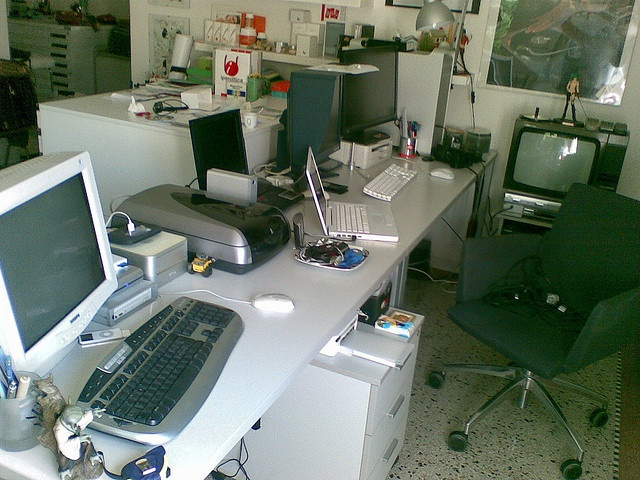Describe the objects in this image and their specific colors. I can see chair in gray and darkgreen tones, tv in gray, teal, white, and darkgray tones, keyboard in gray, black, and teal tones, tv in gray, black, and darkgreen tones, and tv in gray, black, and darkgreen tones in this image. 